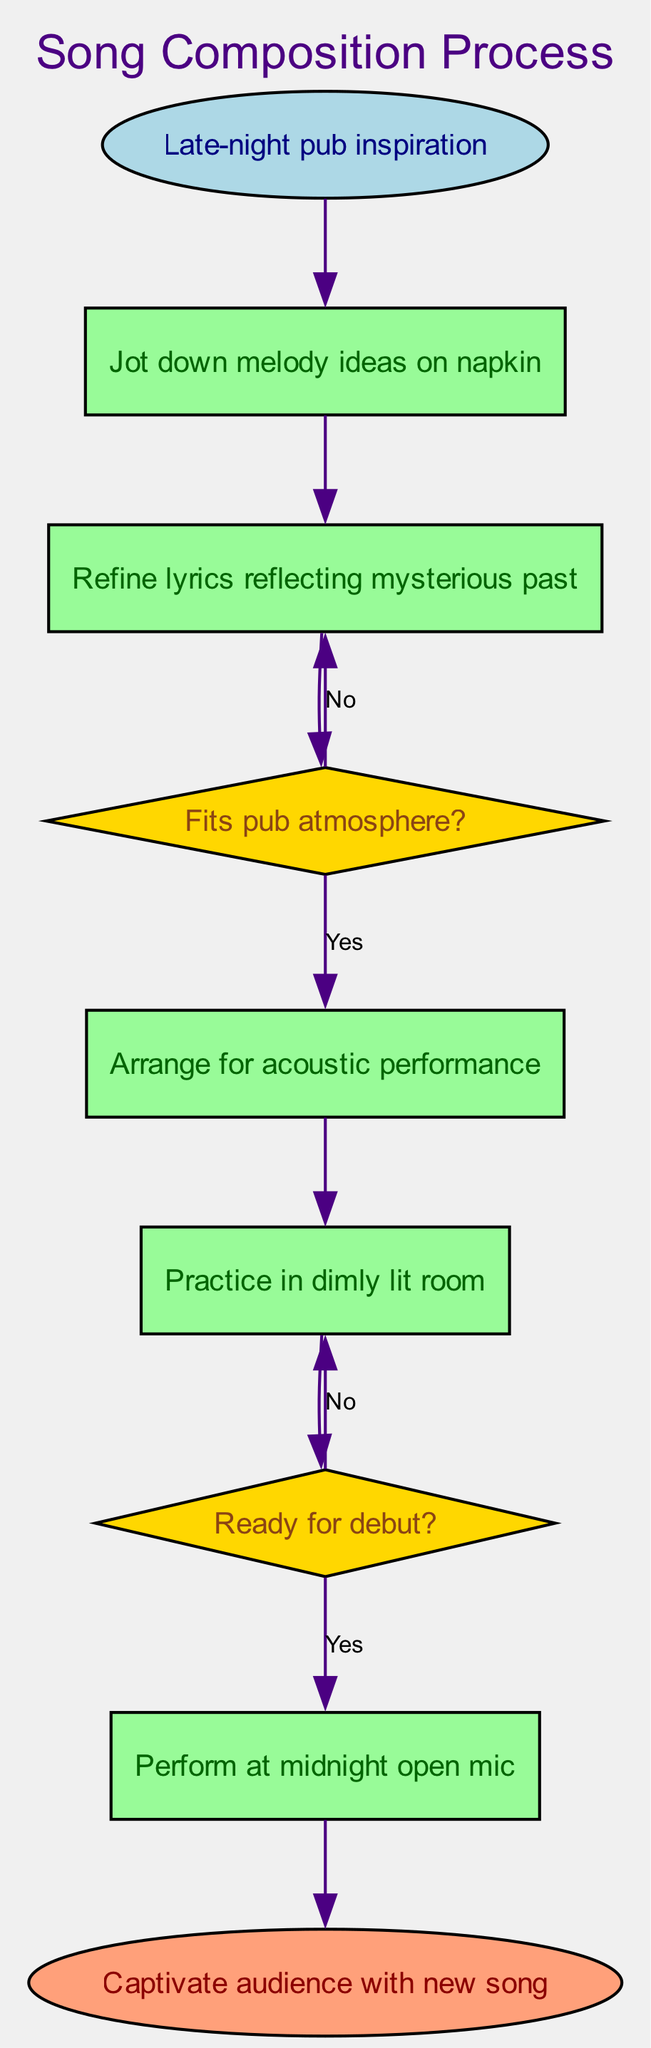What is the starting point of the song composition process? The starting point is indicated by the first node labeled "Late-night pub inspiration," which is the entry point of the flowchart.
Answer: Late-night pub inspiration How many decision points are there in the diagram? To find the number of decision points, we count the nodes labeled as "decision." There are two decision nodes: "Fits pub atmosphere?" and "Ready for debut?"
Answer: 2 What comes after refining lyrics reflecting a mysterious past? The flowchart shows that after "Refine lyrics reflecting mysterious past," the next step is the decision point "Fits pub atmosphere?"
Answer: Fits pub atmosphere? What happens if the song does not fit the pub atmosphere? If the song does not fit the pub atmosphere, the flowchart directs us back to "Refine lyrics reflecting mysterious past," indicating a need for further adjustments.
Answer: Refine lyrics reflecting mysterious past What is the final step in the composition process? The last step of the flowchart, identified by the "end" node, is "Captivate audience with new song," which signifies the conclusion of the process.
Answer: Captivate audience with new song What step follows after arranging for an acoustic performance? According to the diagram, following the "Arrange for acoustic performance" step, the process moves to "Practice in dimly lit room."
Answer: Practice in dimly lit room What is the decision point related to the debut readiness? The decision point that addresses readiness for the debut is labeled "Ready for debut?" which determines whether the performer proceeds or practices more.
Answer: Ready for debut? If practice in a dimly lit room is deemed insufficient, what happens next? If the performer is not ready after practicing in a dimly lit room, the flowchart indicates returning to practice in the same environment again until they are prepared.
Answer: Practice in dimly lit room 